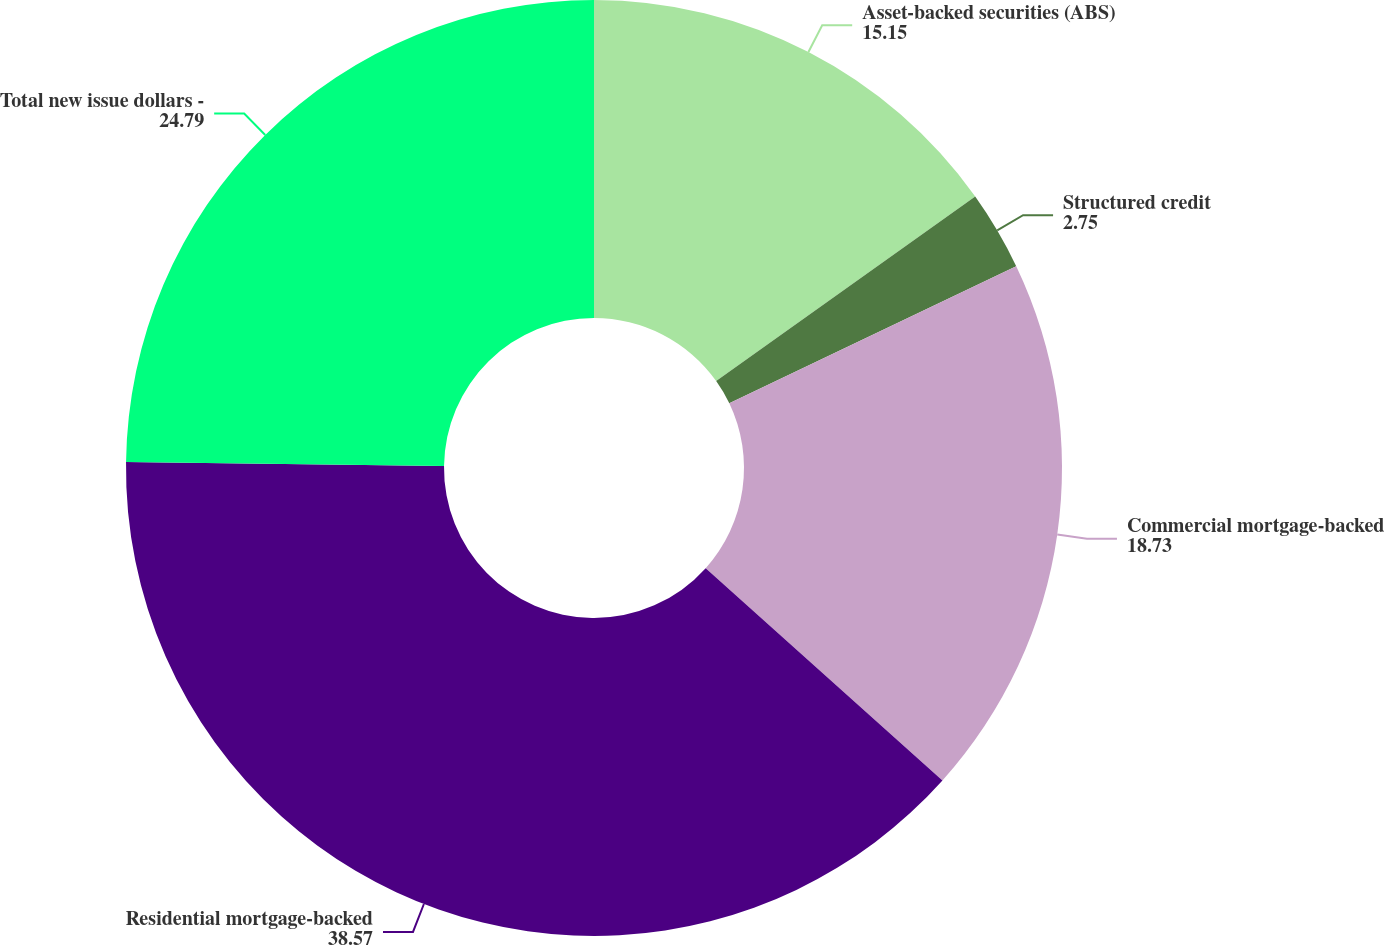<chart> <loc_0><loc_0><loc_500><loc_500><pie_chart><fcel>Asset-backed securities (ABS)<fcel>Structured credit<fcel>Commercial mortgage-backed<fcel>Residential mortgage-backed<fcel>Total new issue dollars -<nl><fcel>15.15%<fcel>2.75%<fcel>18.73%<fcel>38.57%<fcel>24.79%<nl></chart> 